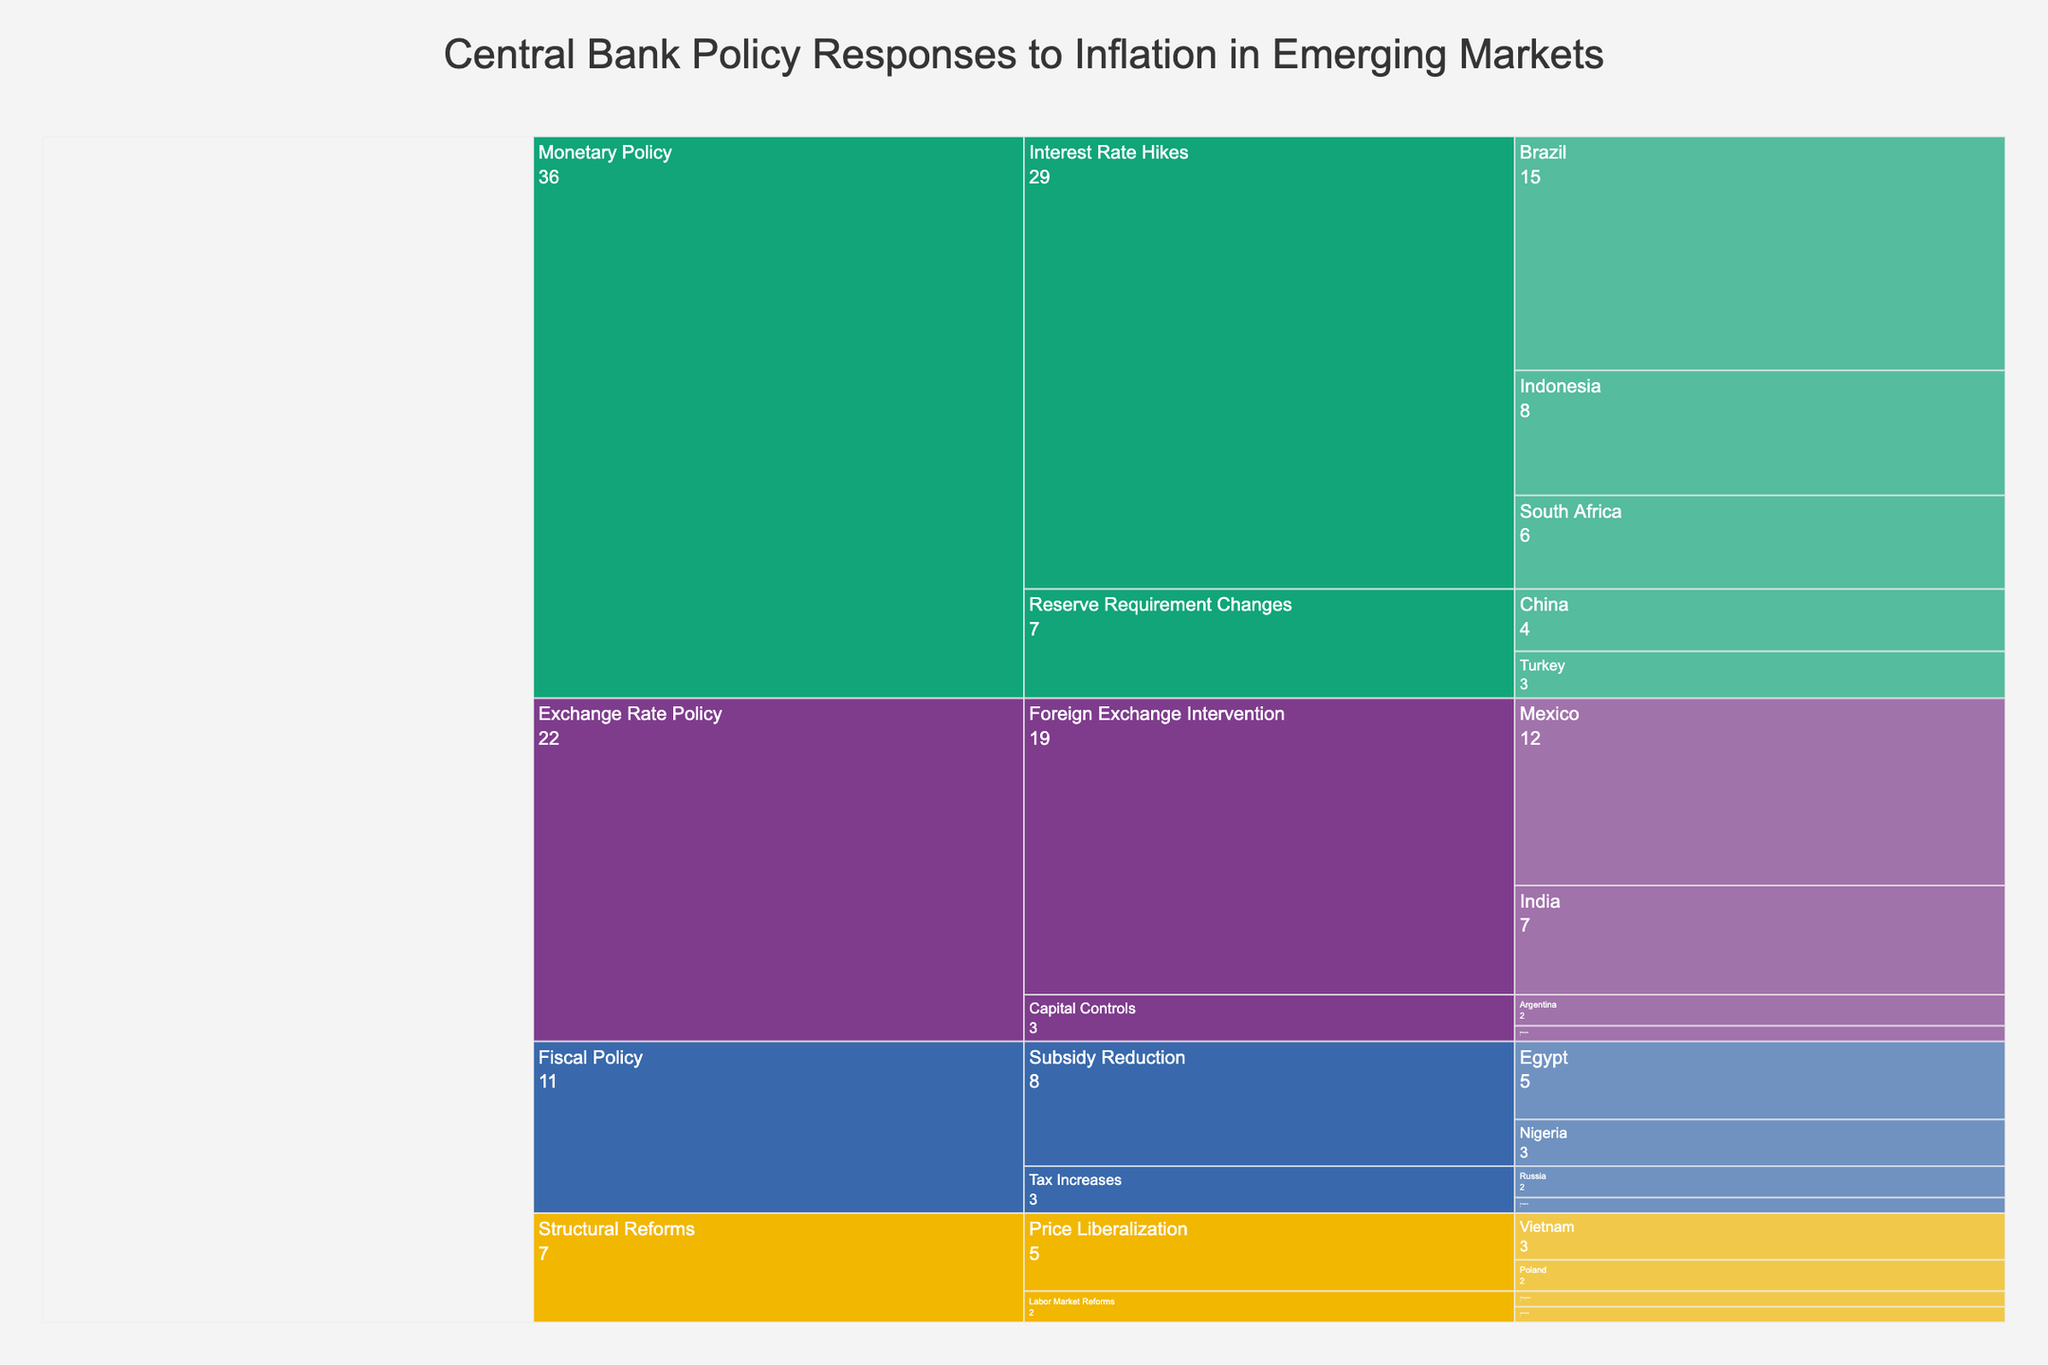1. What is the most frequent intervention type within the Monetary Policy category? The category "Monetary Policy" can be expanded to show two intervention types: "Interest Rate Hikes" and "Reserve Requirement Changes". Summing up the frequencies of each intervention shows that "Interest Rate Hikes" (15 + 8 + 6 = 29) is more frequent than "Reserve Requirement Changes" (4 + 3 = 7).
Answer: Interest Rate Hikes 2. How many countries are involved in Foreign Exchange Intervention under Exchange Rate Policy? Expand the "Exchange Rate Policy" category and then the "Foreign Exchange Intervention" intervention to count the countries. The two countries listed are Mexico and India.
Answer: 2 3. Which country has the highest frequency of any intervention, and what is that frequency? Scan through the entire icicle chart to find the maximum frequency value. "Interest Rate Hikes" in Brazil has a frequency of 15, which is the highest.
Answer: Brazil (15) 4. Compare the total frequency of interventions under Fiscal Policy and Structural Reforms. Which category has more interventions? Sum the frequencies of each intervention type under "Fiscal Policy" and "Structural Reforms". Fiscal Policy: 5 + 3 + 2 + 1 = 11. Structural Reforms: 3 + 2 + 1 + 1 = 7. Fiscal Policy has more interventions.
Answer: Fiscal Policy 5. What is the frequency of interventions in Nigeria under Fiscal Policy? Locate the "Fiscal Policy" category and expand it. Within "Subsidy Reduction", Nigeria is listed with a frequency of 3.
Answer: 3 6. Which intervention under Exchange Rate Policy has the least frequency and what is the count? Expand "Exchange Rate Policy" to see all the listed interventions. "Capital Controls" intervention types have the least frequency with Argentina (2) and Malaysia (1), totaling 3.
Answer: Capital Controls (3) 7. How many countries are represented within the Structural Reforms category? Expand the "Structural Reforms" category and count the distinct countries listed under each intervention type. They are Vietnam, Poland, Colombia, and the Philippines, totaling 4 countries.
Answer: 4 8. What is the total frequency of interventions related to Price Liberalization, and how does it compare with Labor Market Reforms? Expand "Structural Reforms" to find the frequencies. Price Liberalization totals (Vietnam 3 + Poland 2 = 5). Labor Market Reforms totals (Colombia 1 + Philippines 1 = 2). Price Liberalization is more frequent.
Answer: Price Liberalization (5) 9. Which Fiscal Policy intervention involves more countries, Subsidy Reduction or Tax Increases? Expand "Fiscal Policy" to see the countries under each intervention type. Subsidy Reduction involves Egypt and Nigeria (2 countries), while Tax Increases involve Russia and Thailand (2 countries). Both involve the same number of countries.
Answer: Both involve 2 countries 